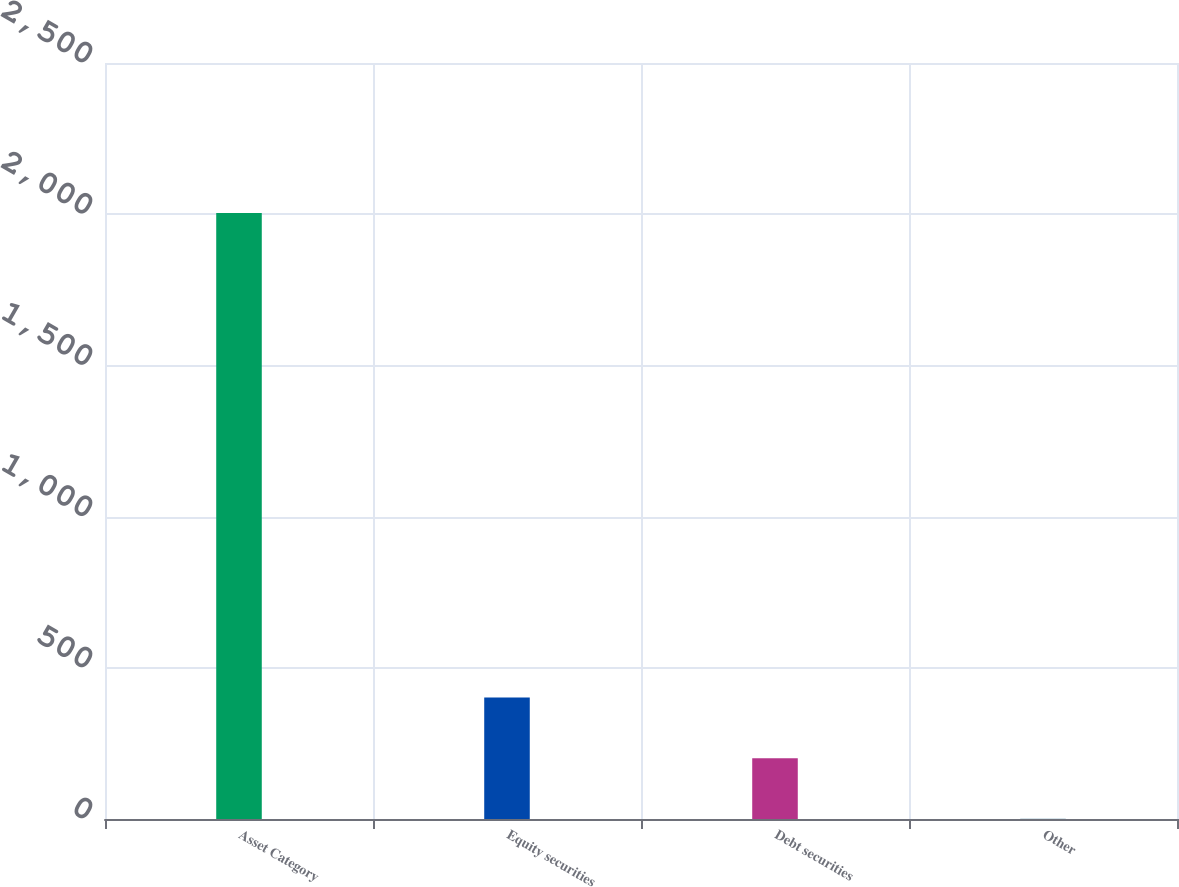Convert chart. <chart><loc_0><loc_0><loc_500><loc_500><bar_chart><fcel>Asset Category<fcel>Equity securities<fcel>Debt securities<fcel>Other<nl><fcel>2004<fcel>401.6<fcel>201.3<fcel>1<nl></chart> 